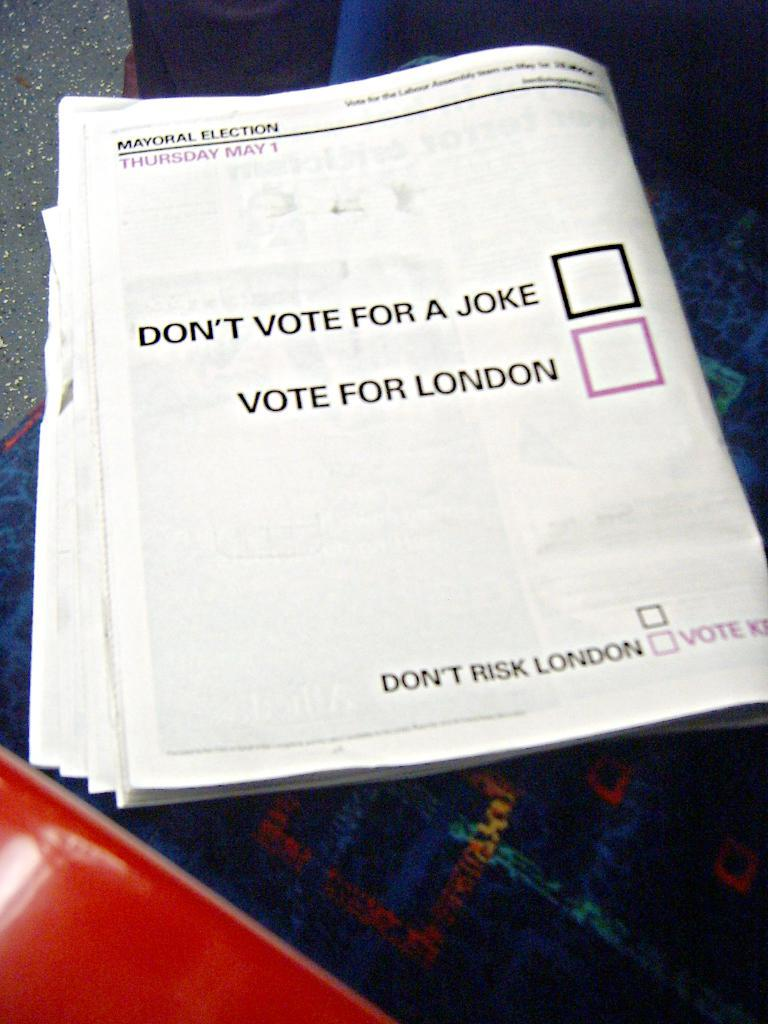Provide a one-sentence caption for the provided image. A newspaper has two check boxes asking you to either not vote for a joke or to vote for london. 